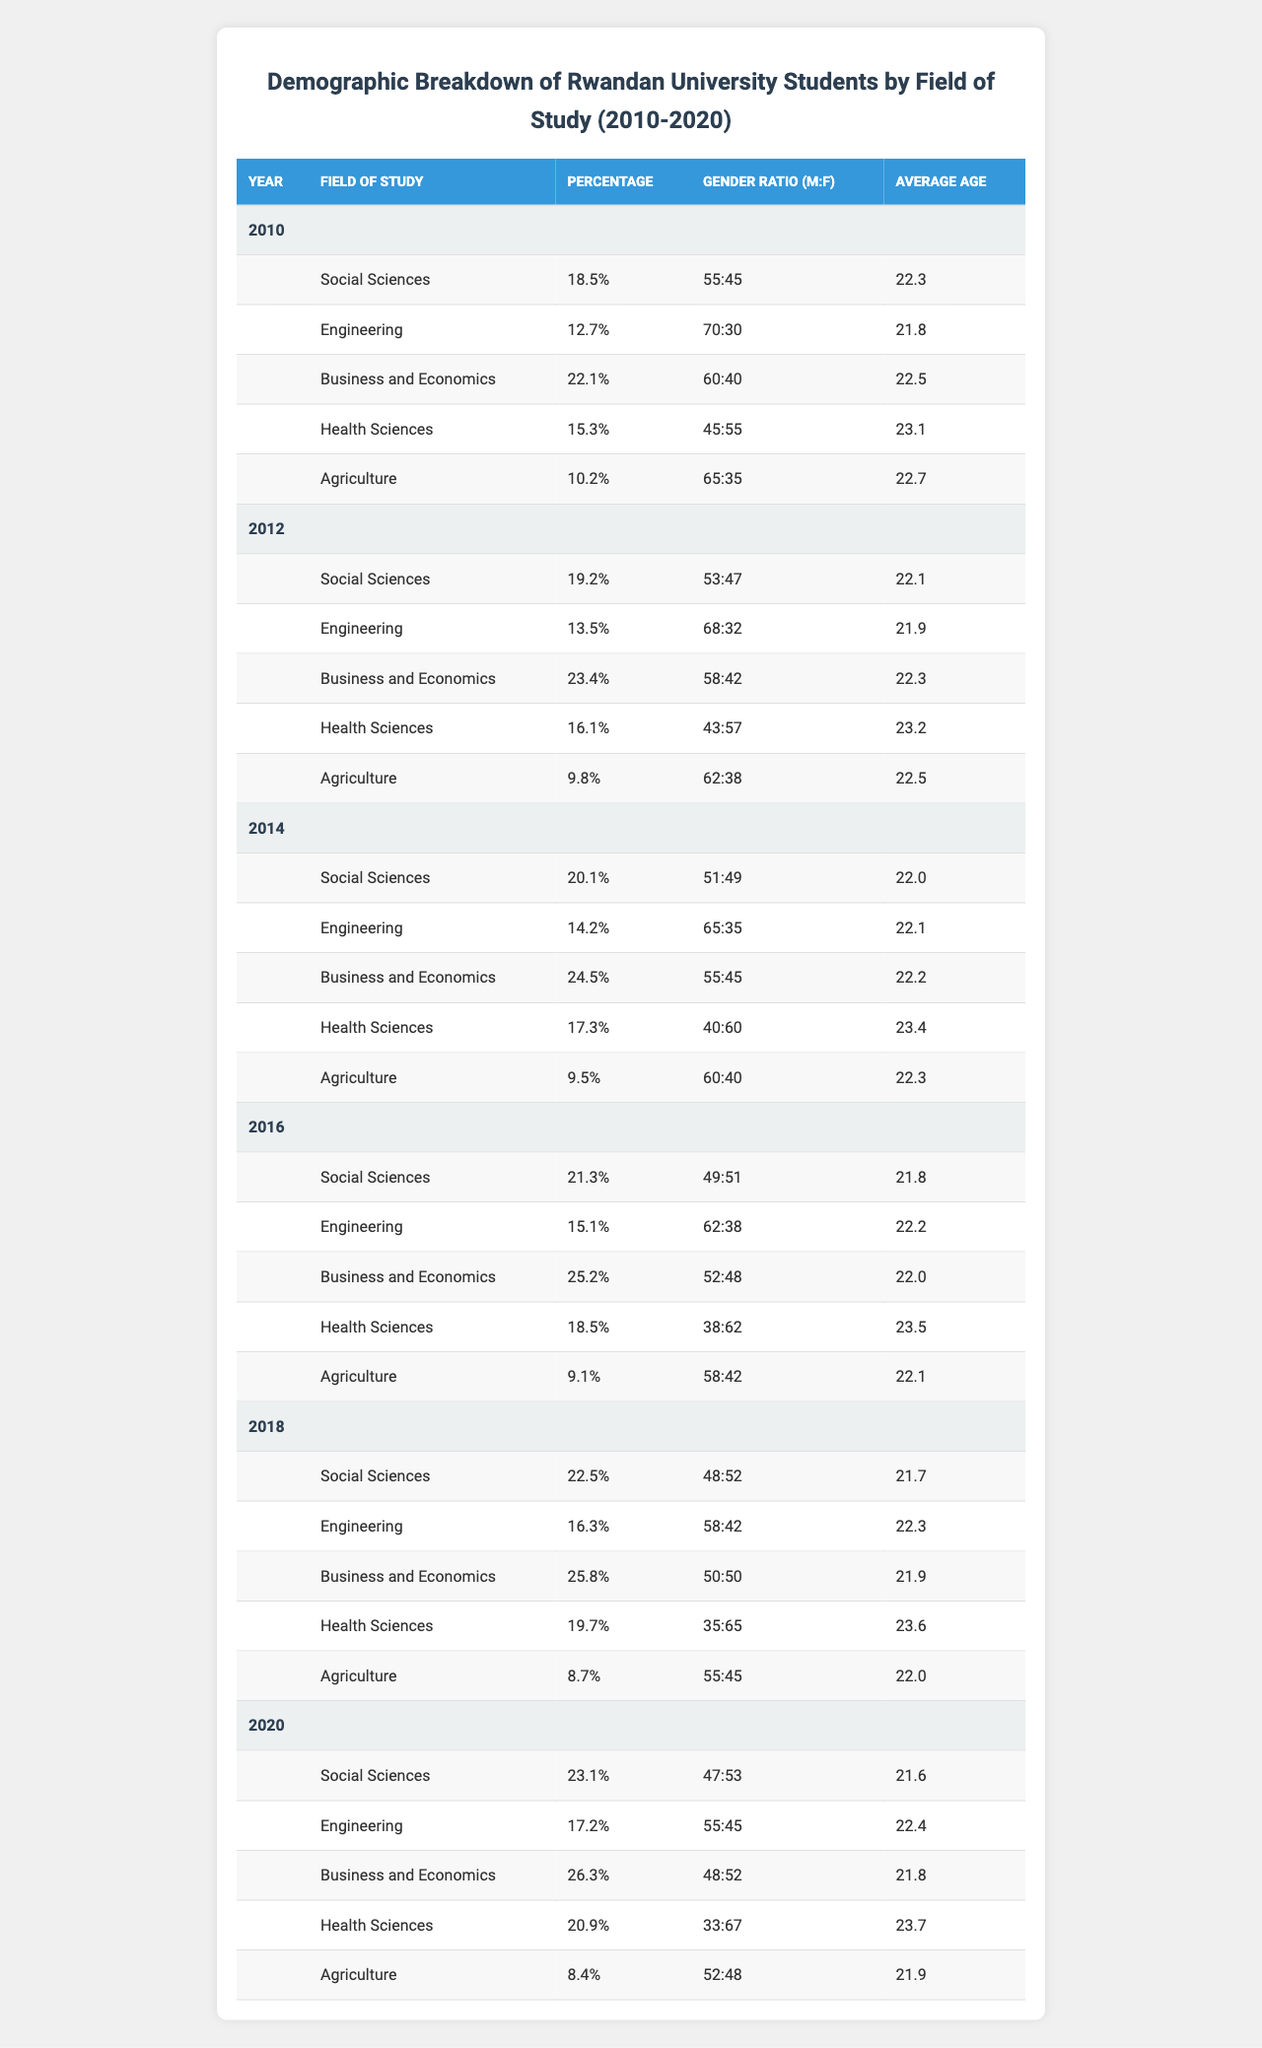What percentage of students studied Business and Economics in 2014? In 2014, the table shows that the percentage of students studying Business and Economics is 24.5%.
Answer: 24.5% What is the gender ratio for Health Sciences in 2020? The gender ratio for Health Sciences in 2020 is presented as 33:67, indicating that there are 33 males for every 67 females.
Answer: 33:67 Which field of study had the highest percentage of students in 2016? In 2016, Business and Economics had the highest percentage of students at 25.2%, compared to other fields.
Answer: 25.2% What was the average age of students in Engineering in 2018? In 2018, the average age of students in Engineering is given as 22.3 years.
Answer: 22.3 years How did the percentage of students studying Agriculture change from 2010 to 2020? In 2010, the percentage of students studying Agriculture was 10.2%, which decreased to 8.4% by 2020. Thus, it decreased by 1.8%.
Answer: Decreased by 1.8% Which field consistently had the lowest percentage of students between 2010 and 2020? The field with the lowest percentage of students throughout the years is Agriculture, with values ranging from 10.2% in 2010 to 8.4% in 2020.
Answer: Agriculture What was the average age of Social Sciences students across all years? To find the average age of Social Sciences students from the years 2010, 2012, 2014, 2016, 2018, and 2020, we sum their ages (22.3 + 22.1 + 22.0 + 21.8 + 21.7 + 21.6 = 132.5) and divide by 6. The average age is approximately 22.08 years.
Answer: Approximately 22.08 years Did the percentage of female students in Engineering increase or decrease from 2010 to 2020? In 2010, the ratio was 70:30 (70% male and 30% female) and in 2020, it was 55:45. This indicates an increase in the percentage of female students in Engineering over this period.
Answer: Increased What year had the highest reported average age across all fields of study? Analyzing the average ages for each year, the highest reported average age was in 2020 for Health Sciences at 23.7 years.
Answer: 23.7 years in 2020 By how much did the percentage of students in Health Sciences increase from 2014 to 2020? In 2014, 17.3% of students were in Health Sciences, which increased to 20.9% in 2020 for an increase of 3.6%.
Answer: Increased by 3.6% What was the gender ratio of students in Business and Economics in 2016 compared to 2020? The gender ratio in 2016 was 52:48 and in 2020 it was 48:52. This shows a shift towards an equal distribution, with more males in 2016 compared to 2020.
Answer: 52:48 in 2016 and 48:52 in 2020 